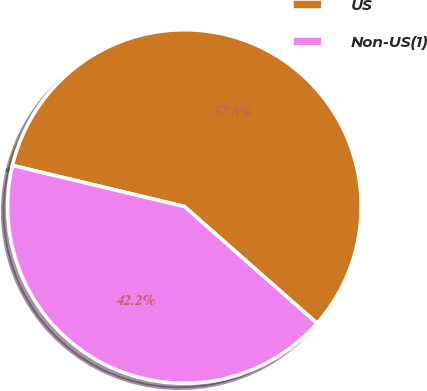Convert chart. <chart><loc_0><loc_0><loc_500><loc_500><pie_chart><fcel>US<fcel>Non-US(1)<nl><fcel>57.76%<fcel>42.24%<nl></chart> 